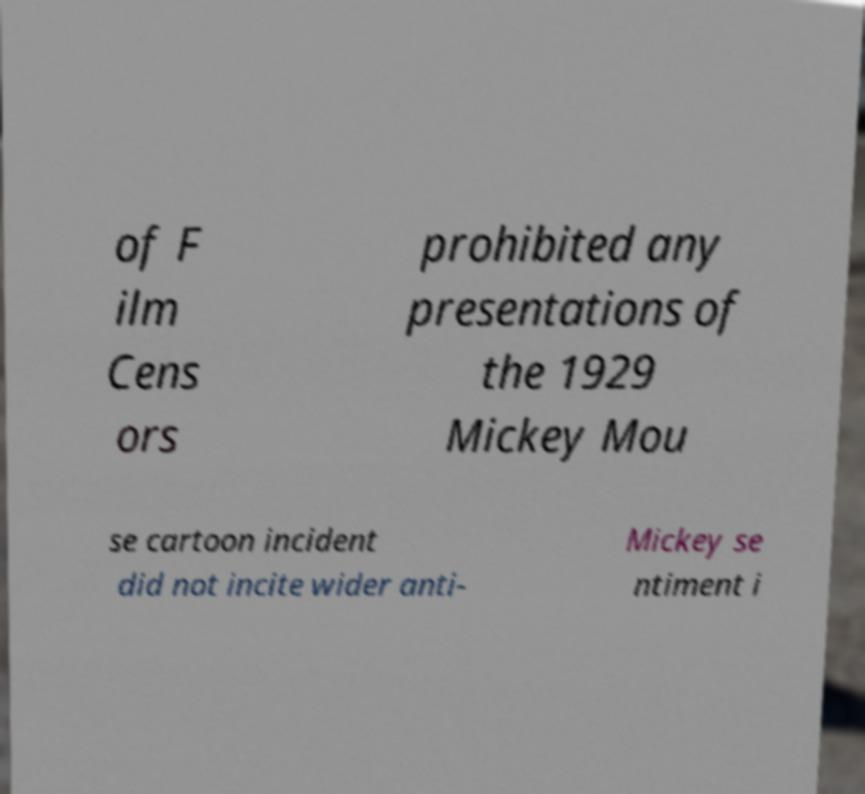What messages or text are displayed in this image? I need them in a readable, typed format. of F ilm Cens ors prohibited any presentations of the 1929 Mickey Mou se cartoon incident did not incite wider anti- Mickey se ntiment i 